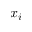Convert formula to latex. <formula><loc_0><loc_0><loc_500><loc_500>x _ { i }</formula> 